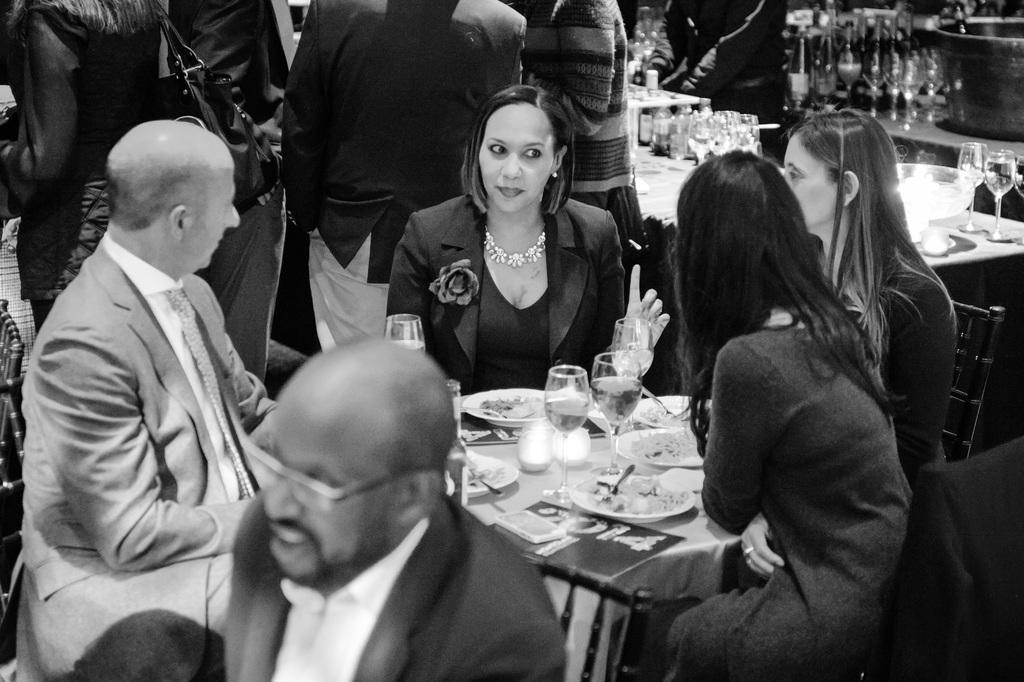How would you summarize this image in a sentence or two? Here we can see a group of persons sitting on the chair, and in front here is the table and glasses and some objects on it, and at back a group of persons are standing, and here are the bottles. 